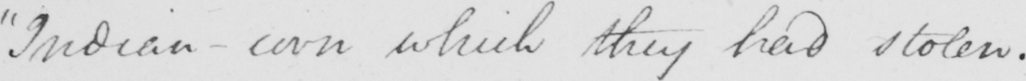What does this handwritten line say? Indian-corn which they had stolen. 